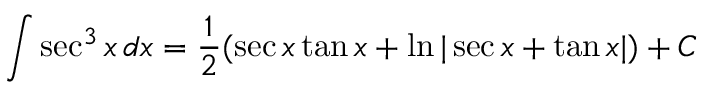Convert formula to latex. <formula><loc_0><loc_0><loc_500><loc_500>\int \sec ^ { 3 } x \, d x = { \frac { 1 } { 2 } } ( \sec x \tan x + \ln | \sec x + \tan x | ) + C</formula> 